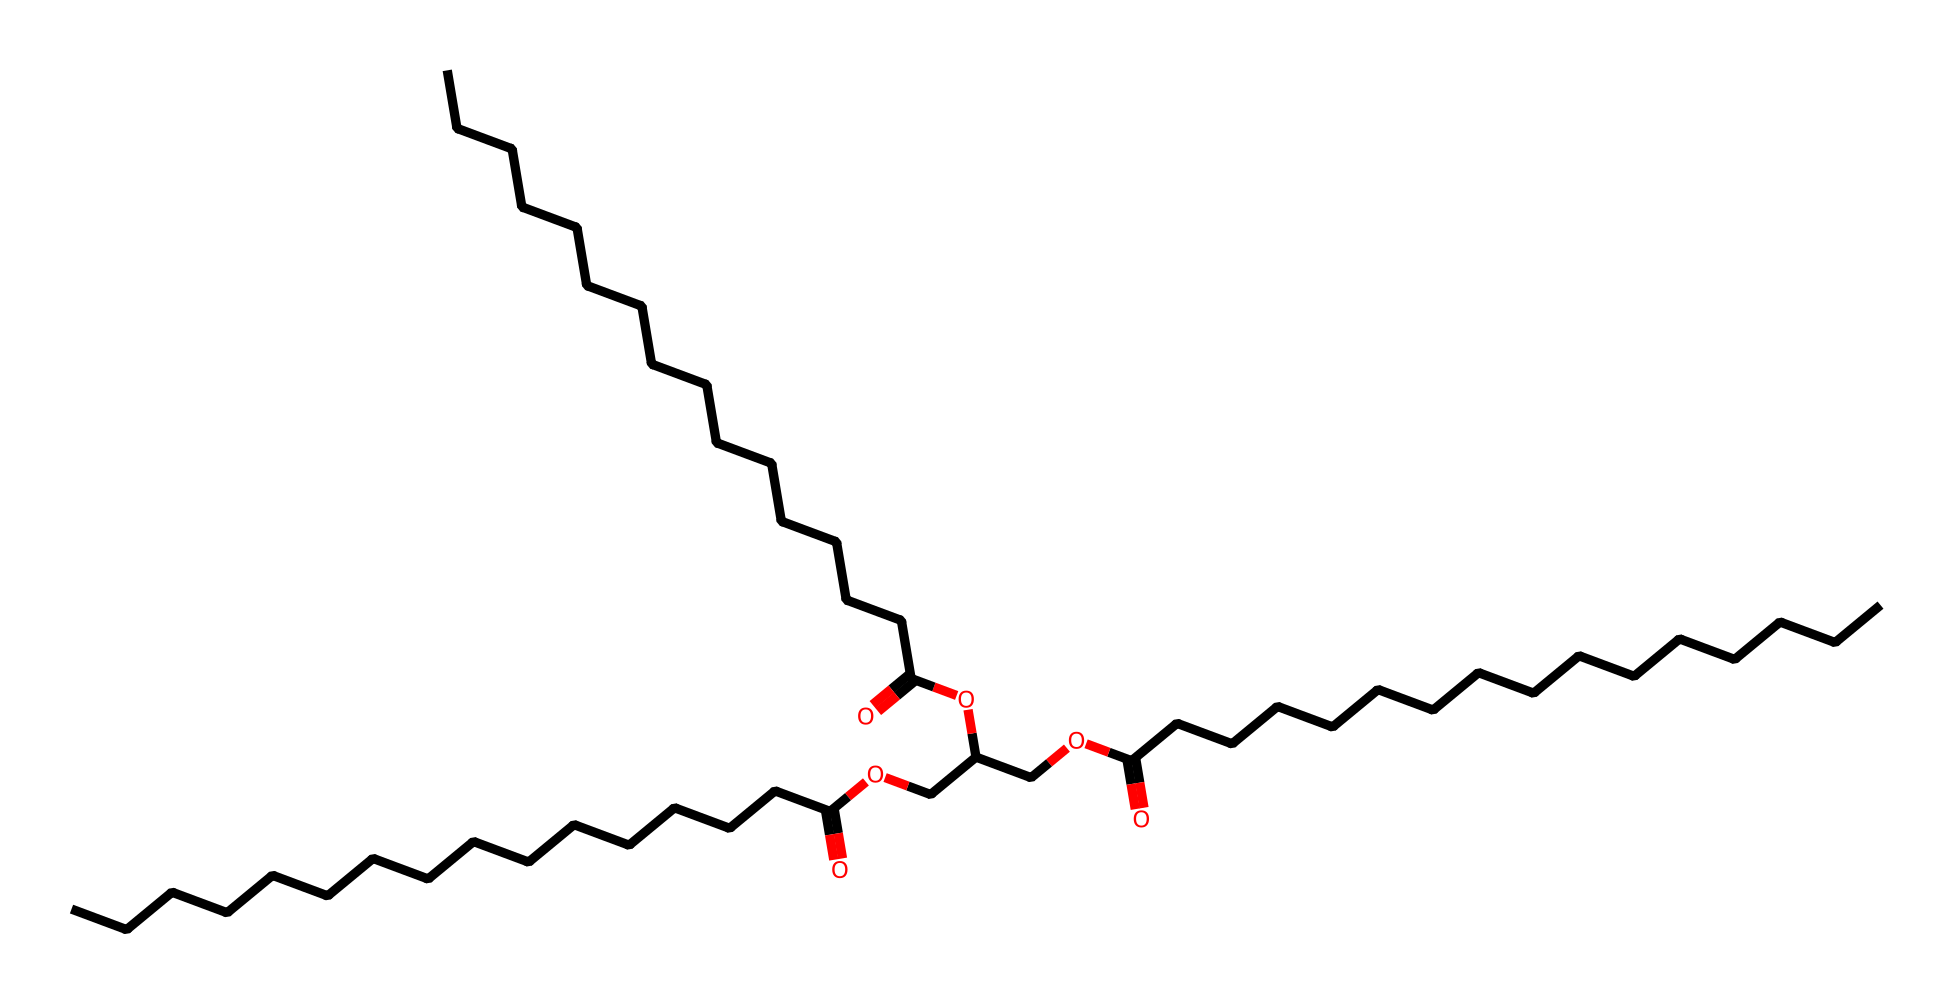What is the main functional group present in this lubricant? The structure contains multiple carboxylic acid groups indicated by the presence of "C(=O)O" in the SMILES representation, which is characteristic of lubricants.
Answer: carboxylic acid How many carbon atoms are in the longest carbon chain? By analyzing the SMILES representation, we can identify the longest continuous carbon chain, which contains 16 carbon atoms before reaching the carboxylic acid.
Answer: 16 What types of bonds are present in this molecule? The chemical structure includes carbon-carbon single bonds and carbon-oxygen double bonds, which are identified by the connectivity in the SMILES string.
Answer: single and double bonds What is the ratio of carbon to oxygen atoms in this lubricant? By counting the carbon (C) and oxygen (O) atoms in the SMILES representation, we find there are 40 carbon atoms and 6 oxygen atoms, giving a ratio of 40:6 or simplified 20:3.
Answer: 20:3 What is the indication of the branching structure in this lubricant? The presence of branches in the carbon chain can be seen in the connectivity provided in the SMILES, which suggests modifications to the lubricant’s viscosity and performance characteristics.
Answer: viscosity 